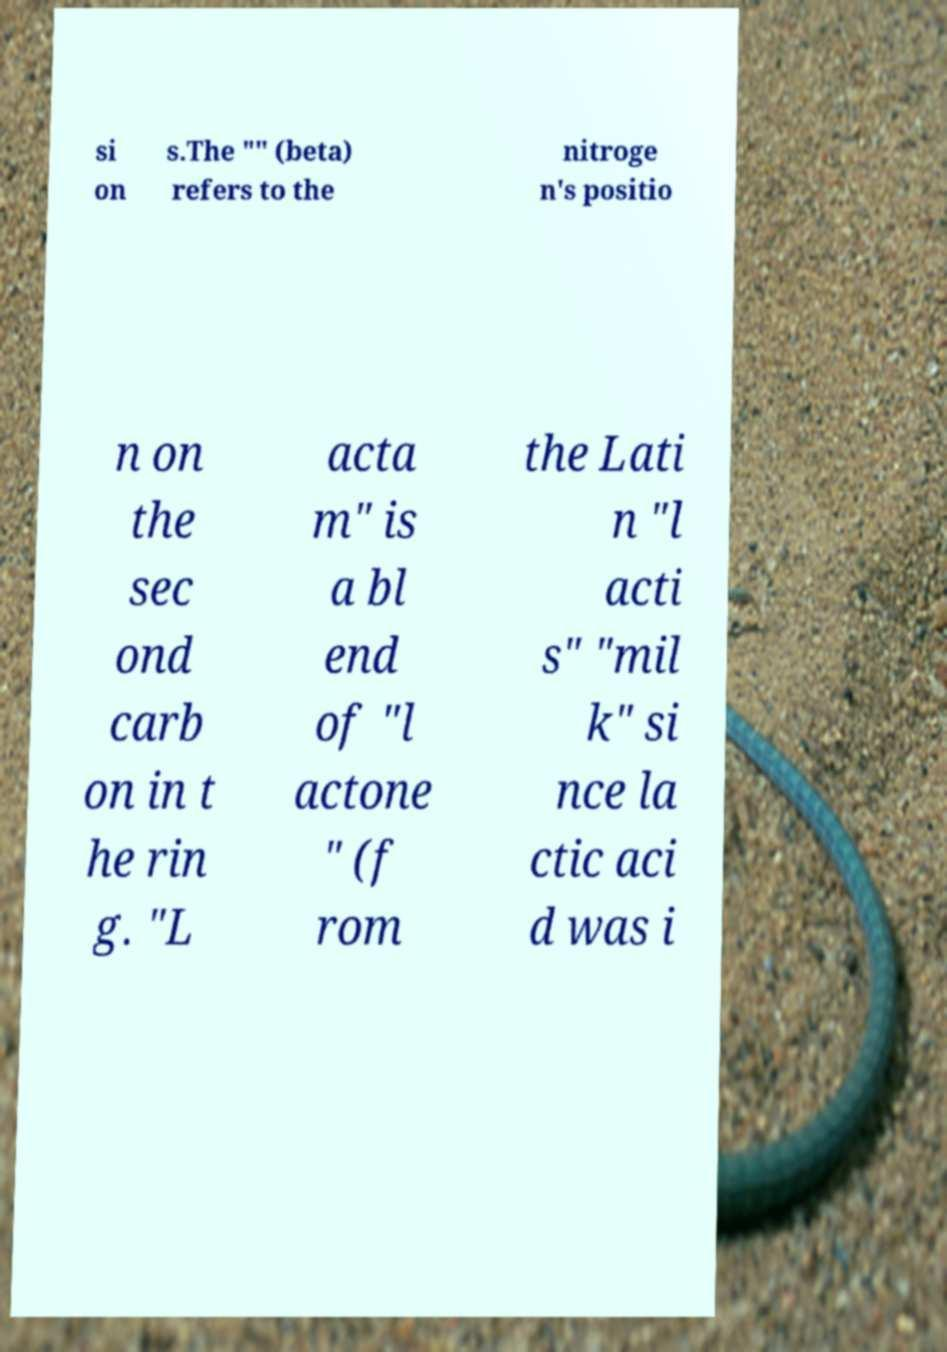Please read and relay the text visible in this image. What does it say? si on s.The "" (beta) refers to the nitroge n's positio n on the sec ond carb on in t he rin g. "L acta m" is a bl end of "l actone " (f rom the Lati n "l acti s" "mil k" si nce la ctic aci d was i 